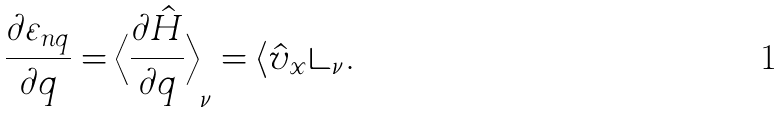Convert formula to latex. <formula><loc_0><loc_0><loc_500><loc_500>\frac { \partial \varepsilon _ { n q } } { \partial q } = \left \langle \frac { \partial \hat { H } } { \partial q } \right \rangle _ { \nu } = \langle \hat { v } _ { x } \rangle _ { \nu } .</formula> 